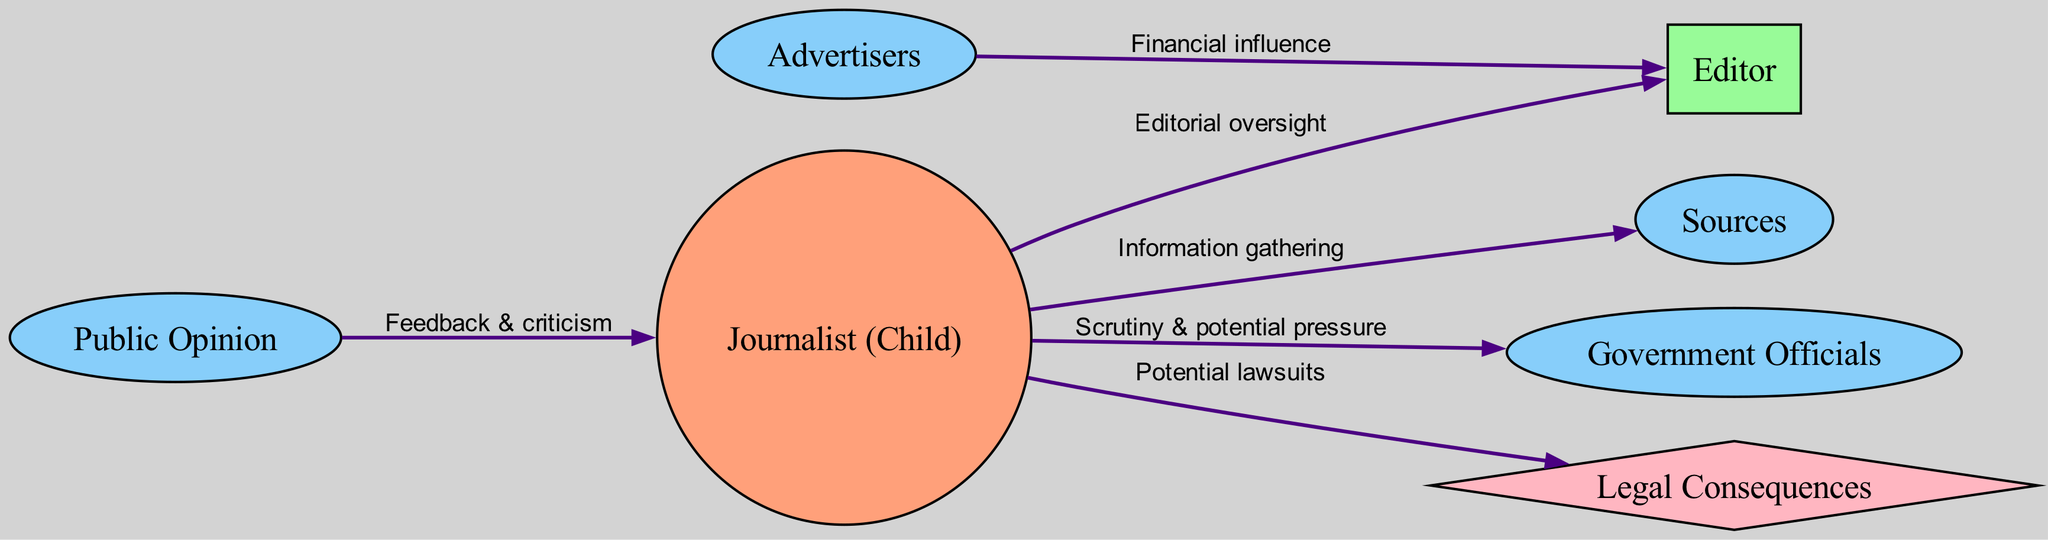What is the central node in this diagram? The central node, which usually represents the primary focus of the analysis, is identified as "Journalist (Child).” This can be determined by examining the node types and noticing that it is marked as 'central.'
Answer: Journalist (Child) How many external nodes are present in the diagram? By counting the nodes categorized as 'external,' we find four: Sources, Government Officials, Advertisers, and Public Opinion. This is done by examining the node type labels in the diagram.
Answer: 4 What is the relationship between the Journalist and the Editor? The relationship is labeled "Editorial oversight," indicating that the journalist reports to the editor for guidance and approval. This can be found by tracing the edge between these two nodes and reading the accompanying label.
Answer: Editorial oversight Which external influence has a financial relationship with the Editor? The Advertisers are noted as having a "Financial influence" over the editor. By highlighting the edge from Advertisers to Editor and reading the label, we identify the nature of this connection.
Answer: Advertisers What type of node is "Legal Consequences"? The "Legal Consequences" node is classified as a 'risk' type. This can be established by examining the node type classifications, where this specific node is marked differently from others.
Answer: risk How many edges connect to the Journalist (Child)? The Journalist (Child) connects to five edges: to Editor, Sources, Government Officials, and two types (Public and Legal). By counting these connections, we find their total.
Answer: 5 What influence does Public Opinion have on the Journalist? Public Opinion provides "Feedback & criticism" to the journalist. This can be confirmed by looking at the direct edge from Public Opinion to Journalist and the label on that edge.
Answer: Feedback & criticism Which node illustrates potential pressure from an external influence? The Government node indicates "Scrutiny & potential pressure" on the journalist, as seen in the labeled edge connecting them. This relationship shows how external stakeholders can impact journalism.
Answer: Government 